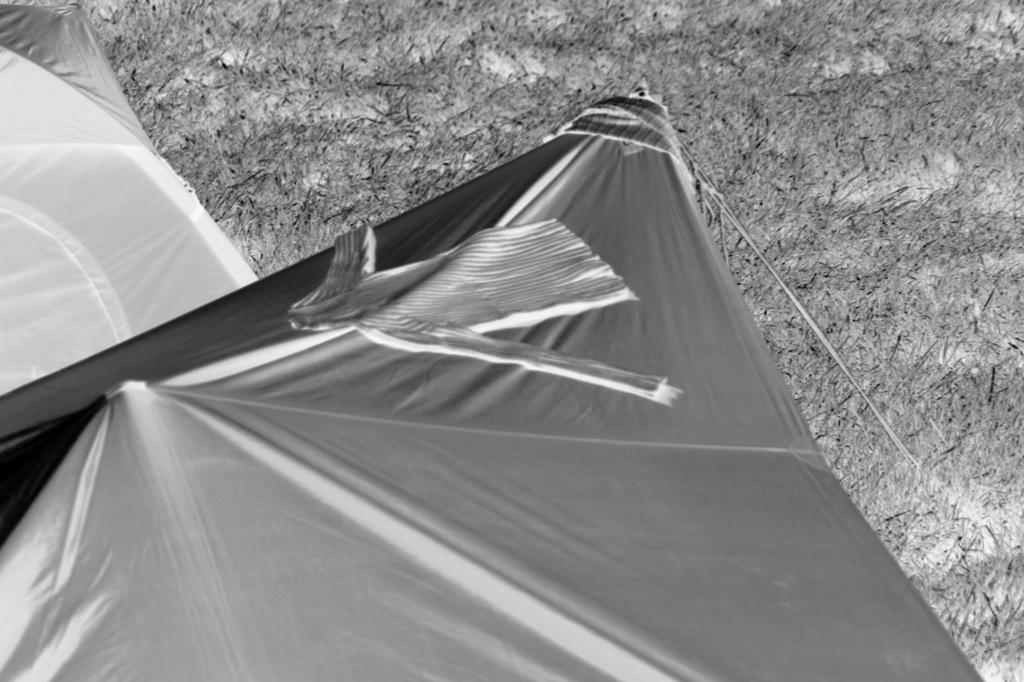What type of structures can be seen in the image? There are tents in the image. What is the color scheme of the image? The image is black and white in color. Can you see a crook walking down the road with a chicken in the image? There is no crook, road, or chicken present in the image; it only features tents in a black and white color scheme. 